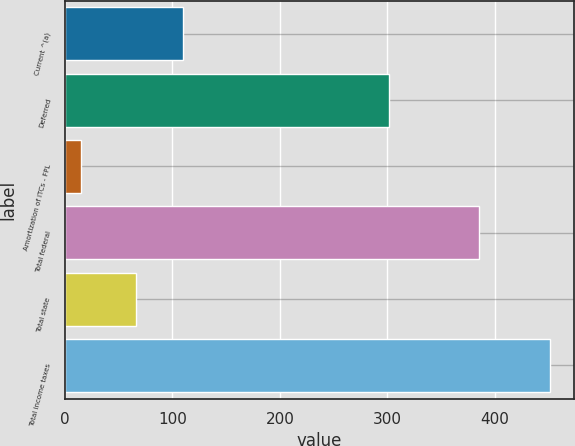<chart> <loc_0><loc_0><loc_500><loc_500><bar_chart><fcel>Current ^(a)<fcel>Deferred<fcel>Amortization of ITCs - FPL<fcel>Total federal<fcel>Total state<fcel>Total income taxes<nl><fcel>109.6<fcel>302<fcel>15<fcel>385<fcel>66<fcel>451<nl></chart> 